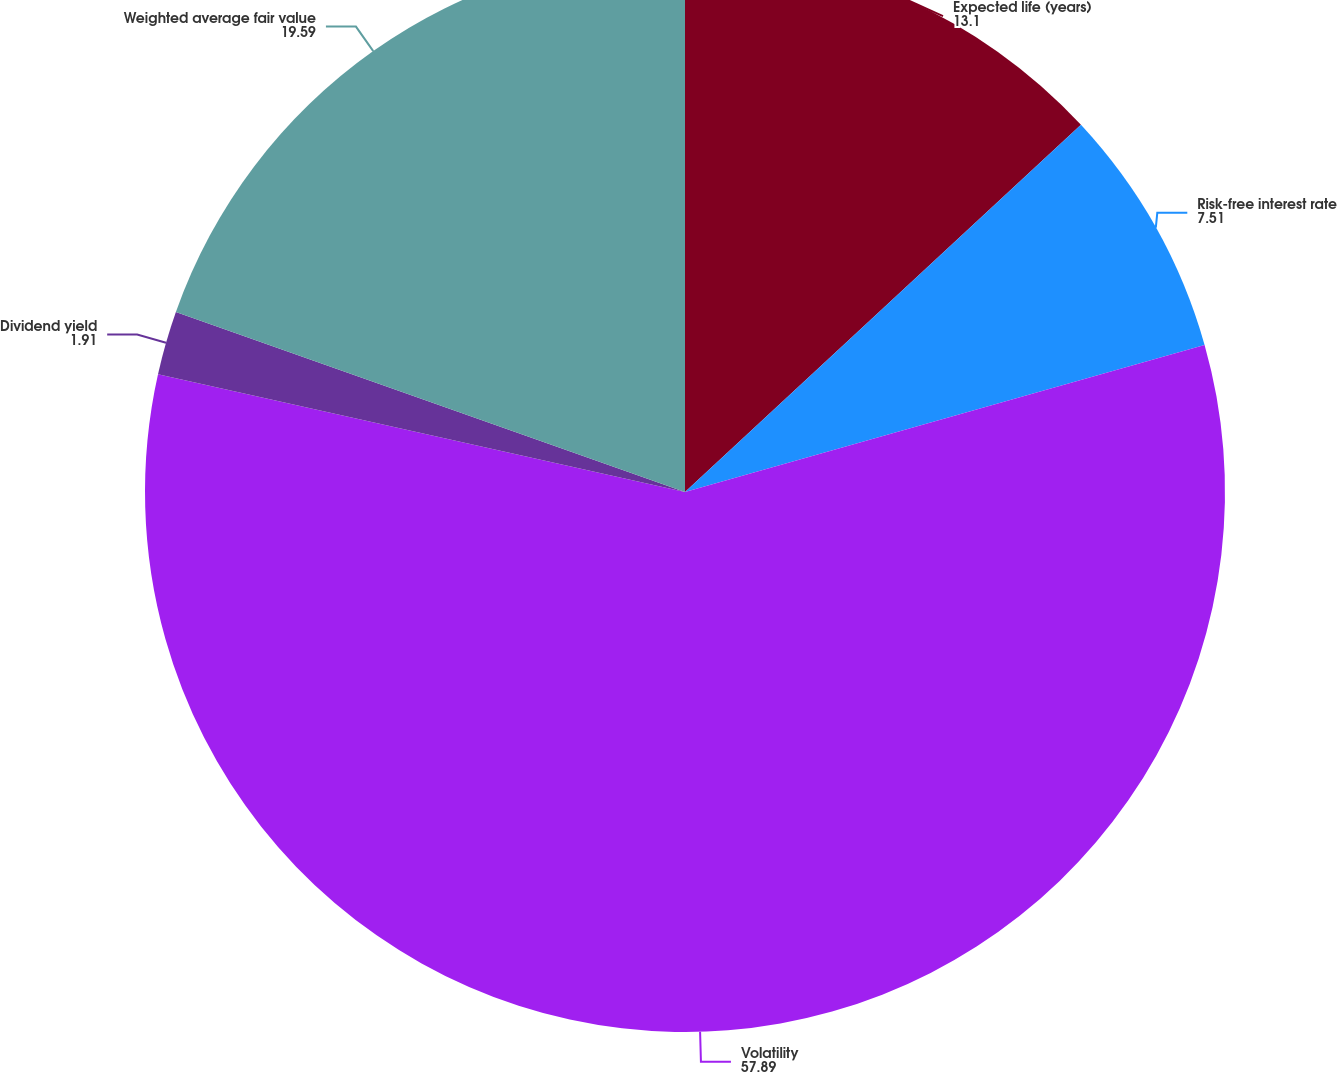Convert chart to OTSL. <chart><loc_0><loc_0><loc_500><loc_500><pie_chart><fcel>Expected life (years)<fcel>Risk-free interest rate<fcel>Volatility<fcel>Dividend yield<fcel>Weighted average fair value<nl><fcel>13.1%<fcel>7.51%<fcel>57.89%<fcel>1.91%<fcel>19.59%<nl></chart> 